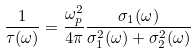Convert formula to latex. <formula><loc_0><loc_0><loc_500><loc_500>\frac { 1 } { \tau ( \omega ) } = \frac { \omega _ { p } ^ { 2 } } { 4 \pi } \frac { \sigma _ { 1 } ( \omega ) } { \sigma _ { 1 } ^ { 2 } ( \omega ) + \sigma _ { 2 } ^ { 2 } ( \omega ) }</formula> 